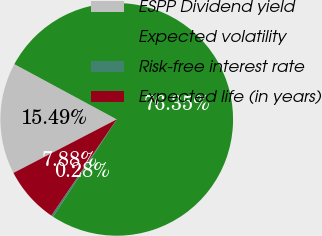<chart> <loc_0><loc_0><loc_500><loc_500><pie_chart><fcel>ESPP Dividend yield<fcel>Expected volatility<fcel>Risk-free interest rate<fcel>Expected life (in years)<nl><fcel>15.49%<fcel>76.35%<fcel>0.28%<fcel>7.88%<nl></chart> 